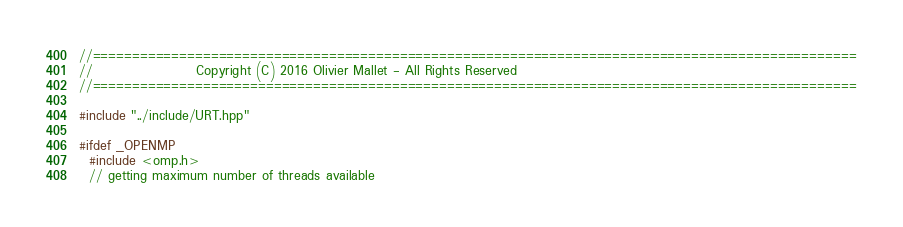<code> <loc_0><loc_0><loc_500><loc_500><_C++_>//=================================================================================================
//                    Copyright (C) 2016 Olivier Mallet - All Rights Reserved                      
//=================================================================================================

#include "../include/URT.hpp"

#ifdef _OPENMP 
  #include <omp.h>
  // getting maximum number of threads available</code> 